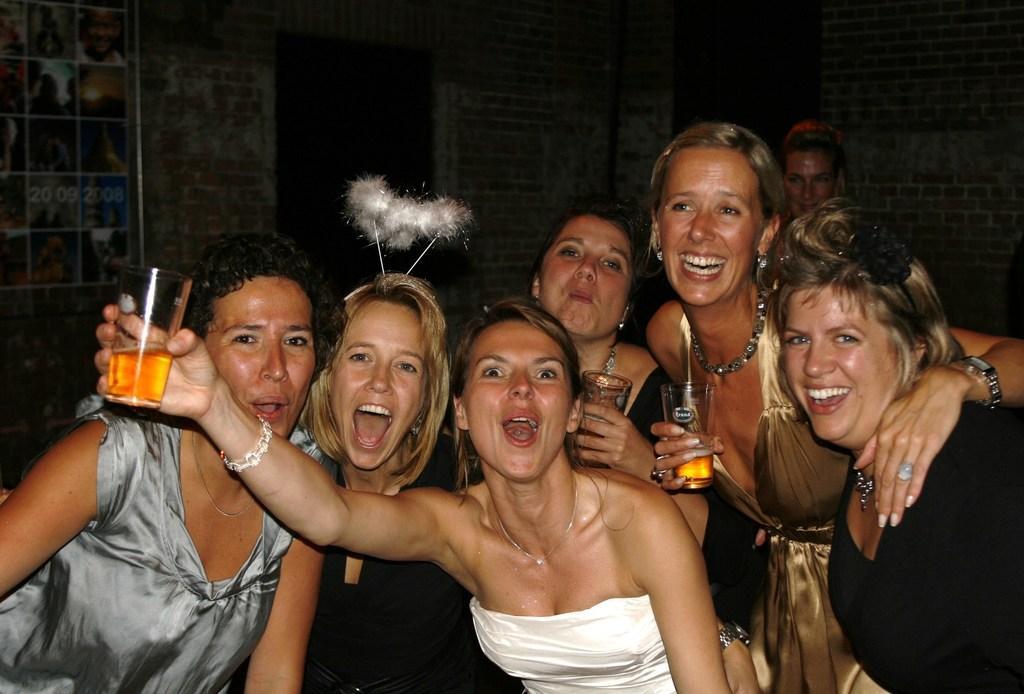Can you describe this image briefly? In this image we can see ladies standing and holding glasses. In the background there is a wall and there is a poster placed on the wall. 